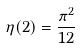<formula> <loc_0><loc_0><loc_500><loc_500>\eta ( 2 ) = \frac { \pi ^ { 2 } } { 1 2 }</formula> 